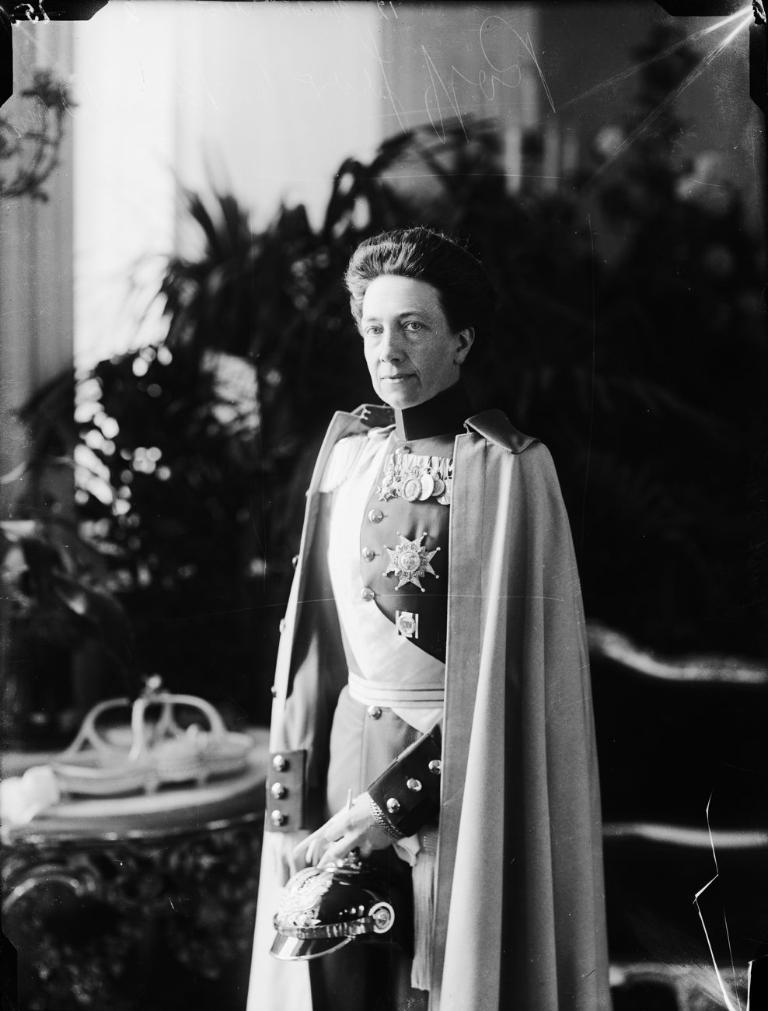Can you describe this image briefly? This is black and white picture where one man is standing he is wearing uniform. Behind him plants are there. 